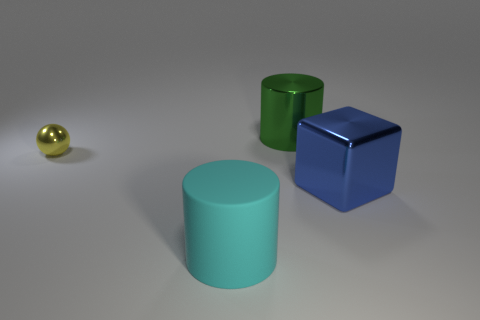Is there any other thing that is made of the same material as the cyan cylinder?
Offer a very short reply. No. Do the metallic object that is in front of the yellow metallic object and the big metallic object behind the yellow metallic thing have the same shape?
Provide a succinct answer. No. Is there any other thing that is the same size as the yellow sphere?
Provide a succinct answer. No. How many cubes are either small rubber objects or tiny metal things?
Give a very brief answer. 0. Is the material of the large cyan object the same as the blue block?
Your answer should be very brief. No. What number of other things are there of the same color as the rubber thing?
Make the answer very short. 0. The object left of the big cyan object has what shape?
Provide a short and direct response. Sphere. What number of objects are either blue cubes or yellow metallic cubes?
Give a very brief answer. 1. Does the green shiny thing have the same size as the object in front of the metallic block?
Your answer should be compact. Yes. What number of other things are there of the same material as the large cyan cylinder
Give a very brief answer. 0. 